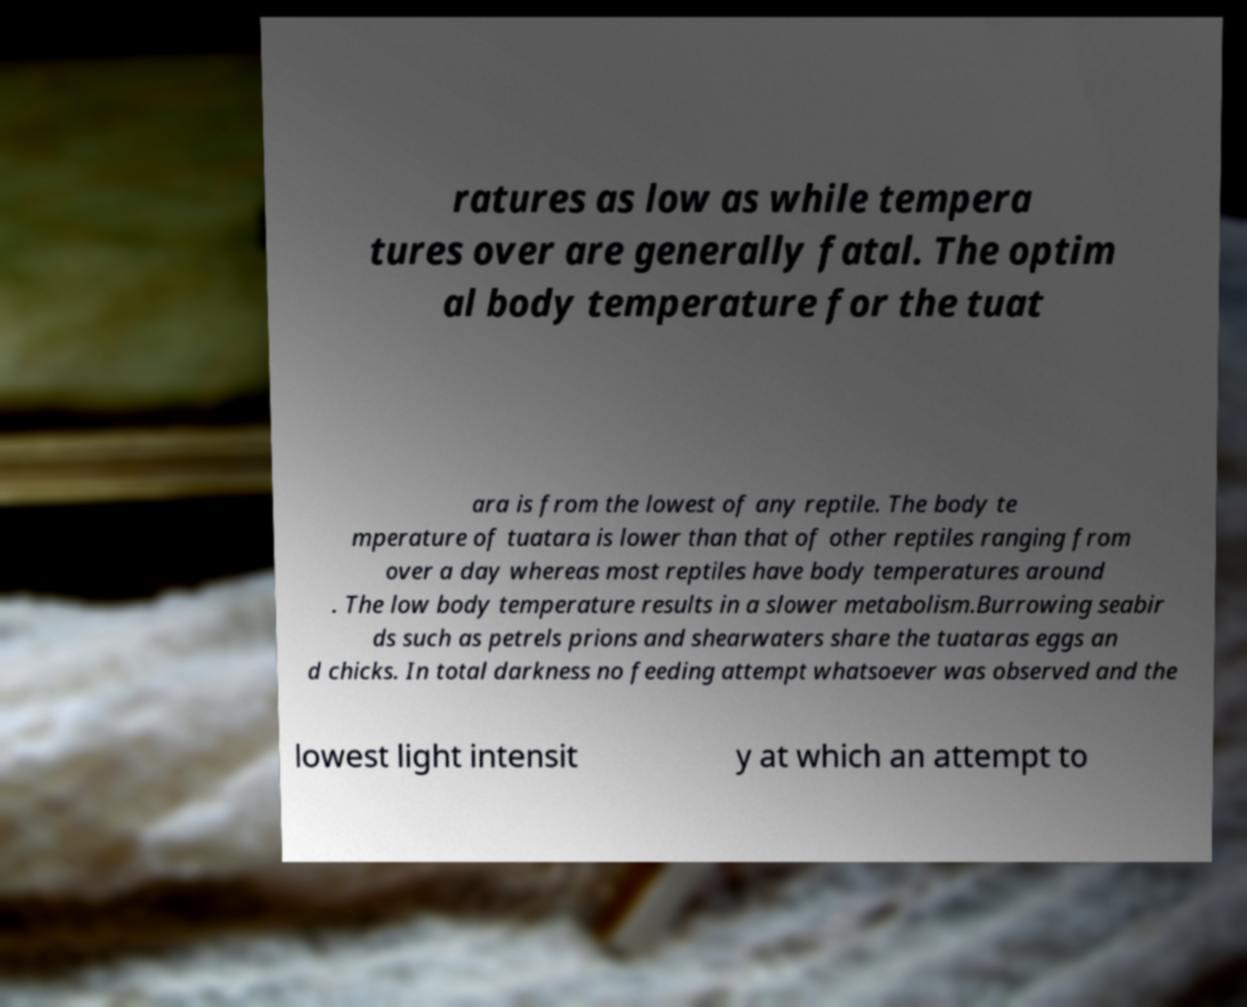There's text embedded in this image that I need extracted. Can you transcribe it verbatim? ratures as low as while tempera tures over are generally fatal. The optim al body temperature for the tuat ara is from the lowest of any reptile. The body te mperature of tuatara is lower than that of other reptiles ranging from over a day whereas most reptiles have body temperatures around . The low body temperature results in a slower metabolism.Burrowing seabir ds such as petrels prions and shearwaters share the tuataras eggs an d chicks. In total darkness no feeding attempt whatsoever was observed and the lowest light intensit y at which an attempt to 